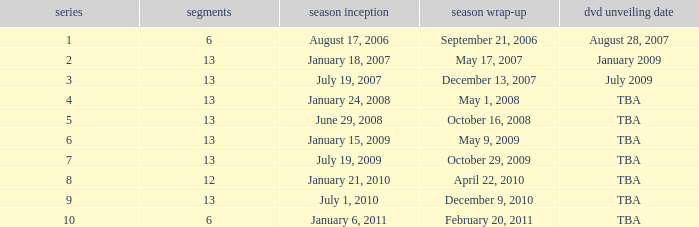On what date was the DVD released for the season with fewer than 13 episodes that aired before season 8? August 28, 2007. 